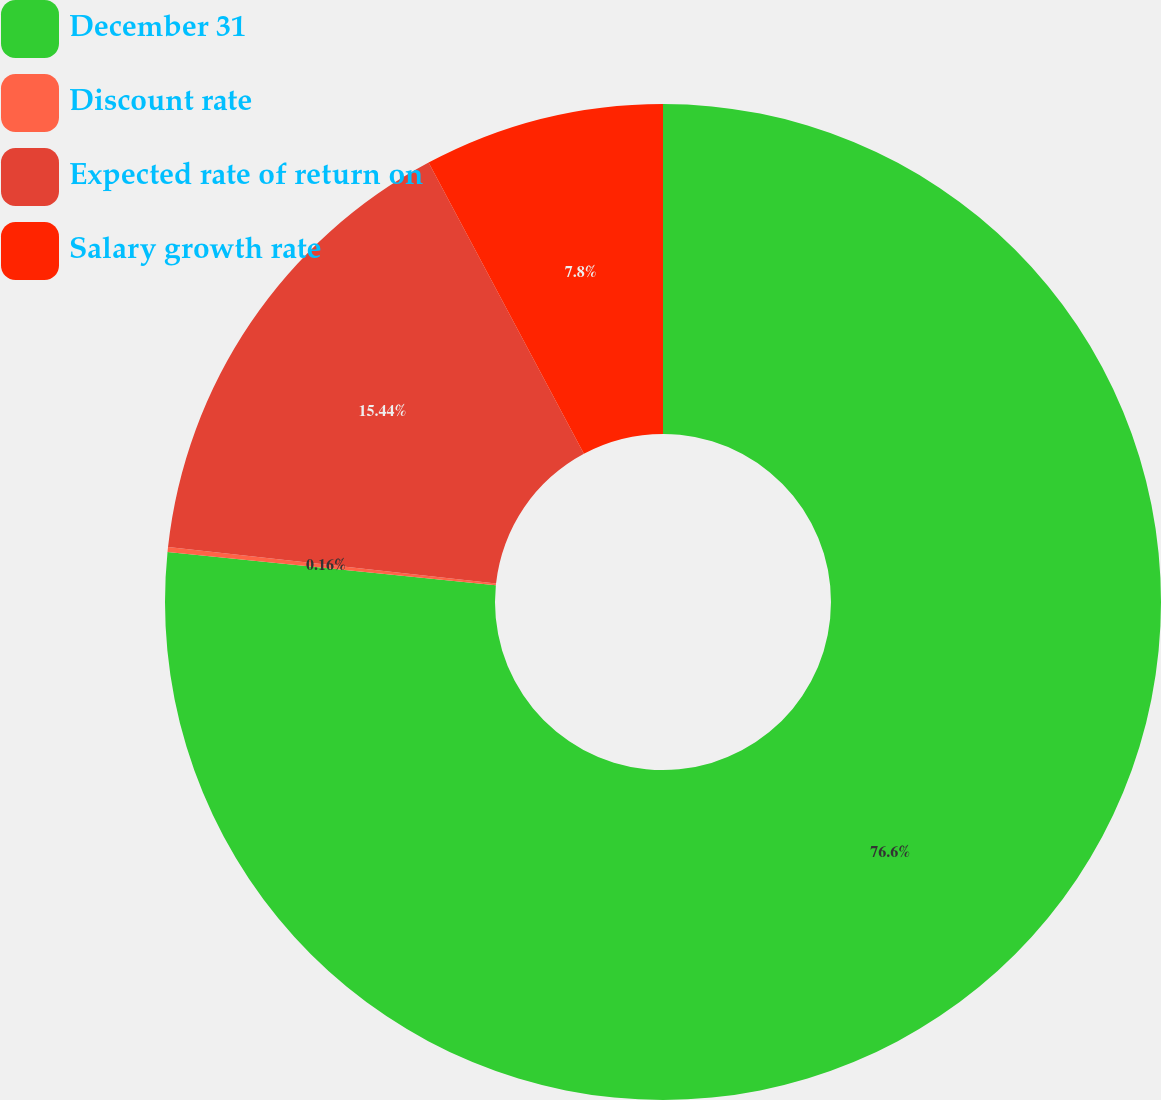Convert chart to OTSL. <chart><loc_0><loc_0><loc_500><loc_500><pie_chart><fcel>December 31<fcel>Discount rate<fcel>Expected rate of return on<fcel>Salary growth rate<nl><fcel>76.6%<fcel>0.16%<fcel>15.44%<fcel>7.8%<nl></chart> 